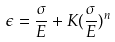Convert formula to latex. <formula><loc_0><loc_0><loc_500><loc_500>\epsilon = \frac { \sigma } { E } + K ( \frac { \sigma } { E } ) ^ { n }</formula> 